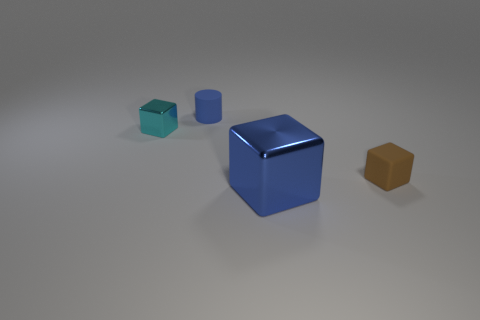How many objects are rubber objects that are to the right of the blue block or matte objects in front of the small cyan thing?
Give a very brief answer. 1. Are there any other things that are the same color as the rubber cylinder?
Provide a succinct answer. Yes. Are there the same number of tiny brown matte things to the left of the big blue block and big blue blocks behind the rubber block?
Make the answer very short. Yes. Are there more things behind the tiny rubber cube than brown matte cubes?
Your answer should be compact. Yes. How many objects are either tiny cubes on the right side of the large blue metal block or cyan shiny objects?
Offer a very short reply. 2. How many large blue objects are made of the same material as the blue cylinder?
Make the answer very short. 0. The tiny matte object that is the same color as the big metallic thing is what shape?
Keep it short and to the point. Cylinder. Is there another big metallic object of the same shape as the blue metal thing?
Ensure brevity in your answer.  No. There is a brown object that is the same size as the cyan cube; what is its shape?
Your answer should be compact. Cube. There is a big metallic block; is its color the same as the tiny matte thing behind the cyan shiny cube?
Provide a succinct answer. Yes. 